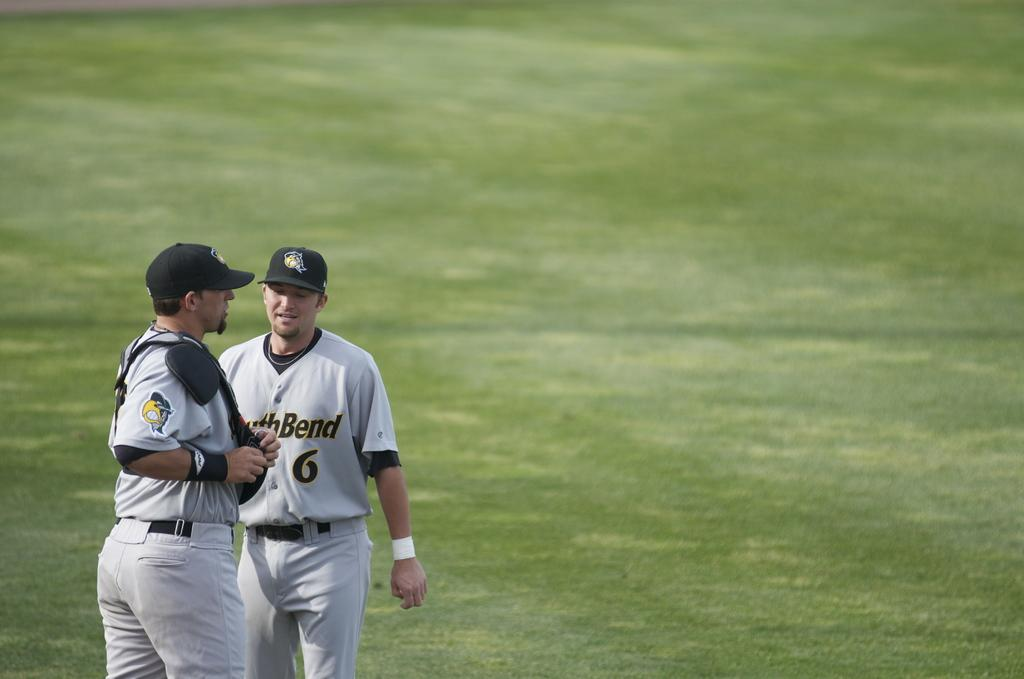<image>
Offer a succinct explanation of the picture presented. Two baseball players stand on a field and one is wearing a number 6 jersey. 